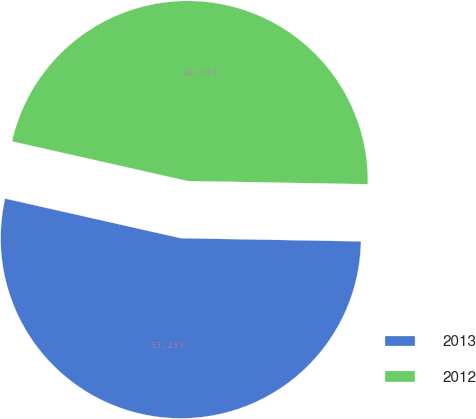Convert chart to OTSL. <chart><loc_0><loc_0><loc_500><loc_500><pie_chart><fcel>2013<fcel>2012<nl><fcel>53.25%<fcel>46.75%<nl></chart> 